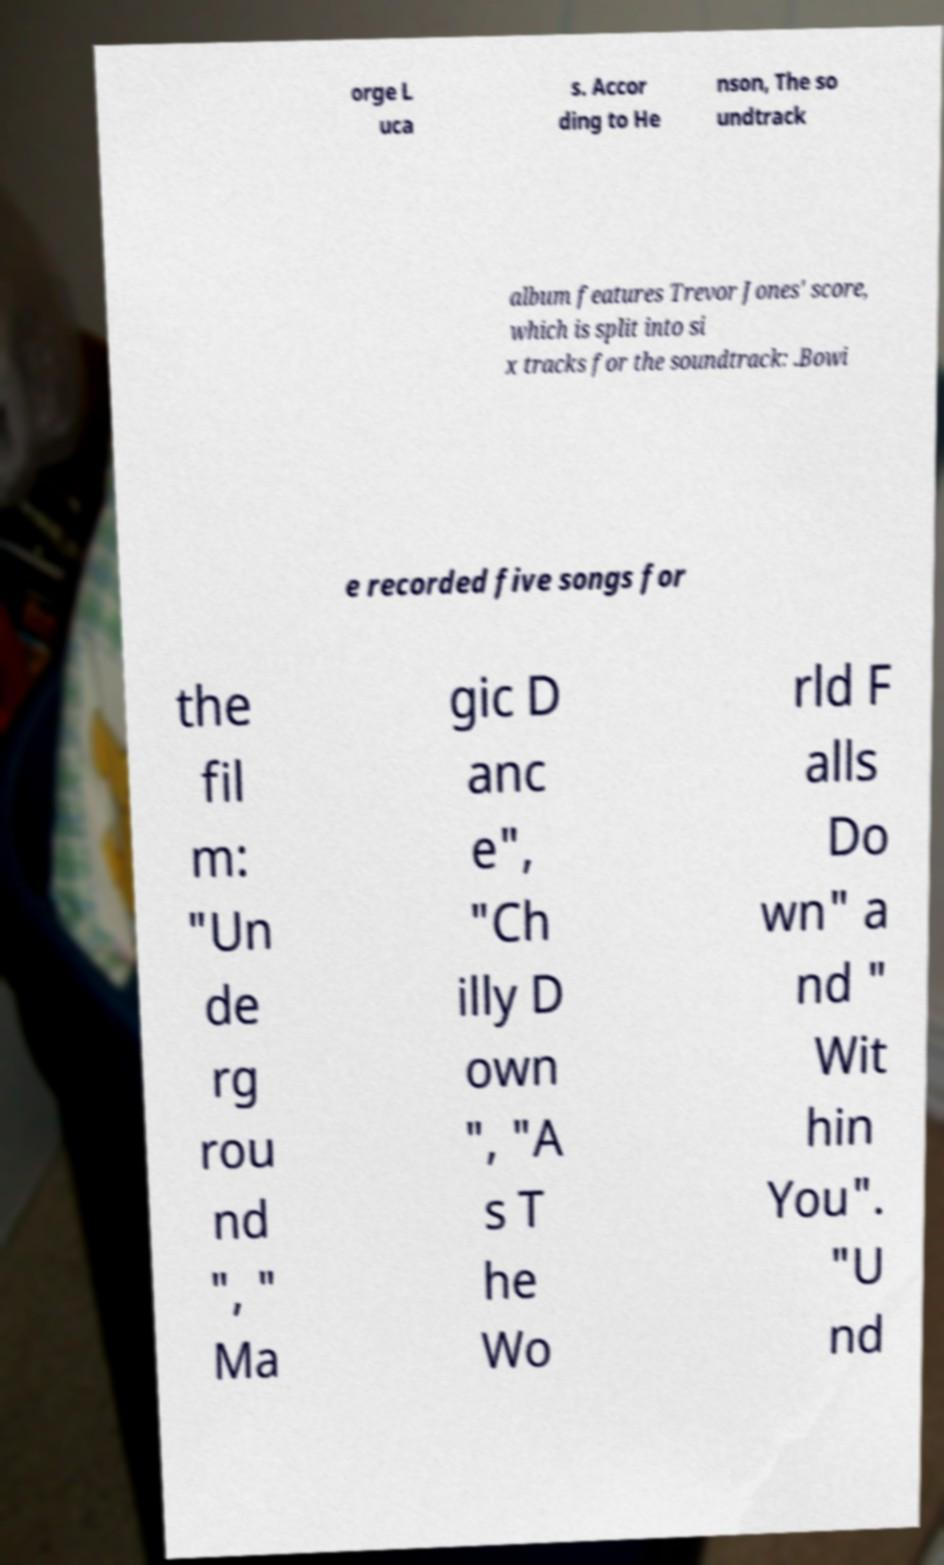What messages or text are displayed in this image? I need them in a readable, typed format. orge L uca s. Accor ding to He nson, The so undtrack album features Trevor Jones' score, which is split into si x tracks for the soundtrack: .Bowi e recorded five songs for the fil m: "Un de rg rou nd ", " Ma gic D anc e", "Ch illy D own ", "A s T he Wo rld F alls Do wn" a nd " Wit hin You". "U nd 